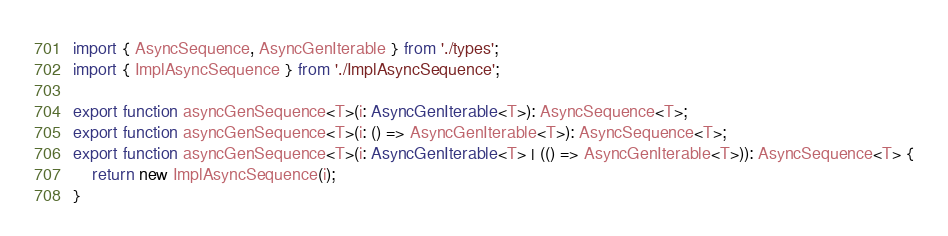<code> <loc_0><loc_0><loc_500><loc_500><_TypeScript_>import { AsyncSequence, AsyncGenIterable } from './types';
import { ImplAsyncSequence } from './ImplAsyncSequence';

export function asyncGenSequence<T>(i: AsyncGenIterable<T>): AsyncSequence<T>;
export function asyncGenSequence<T>(i: () => AsyncGenIterable<T>): AsyncSequence<T>;
export function asyncGenSequence<T>(i: AsyncGenIterable<T> | (() => AsyncGenIterable<T>)): AsyncSequence<T> {
    return new ImplAsyncSequence(i);
}</code> 